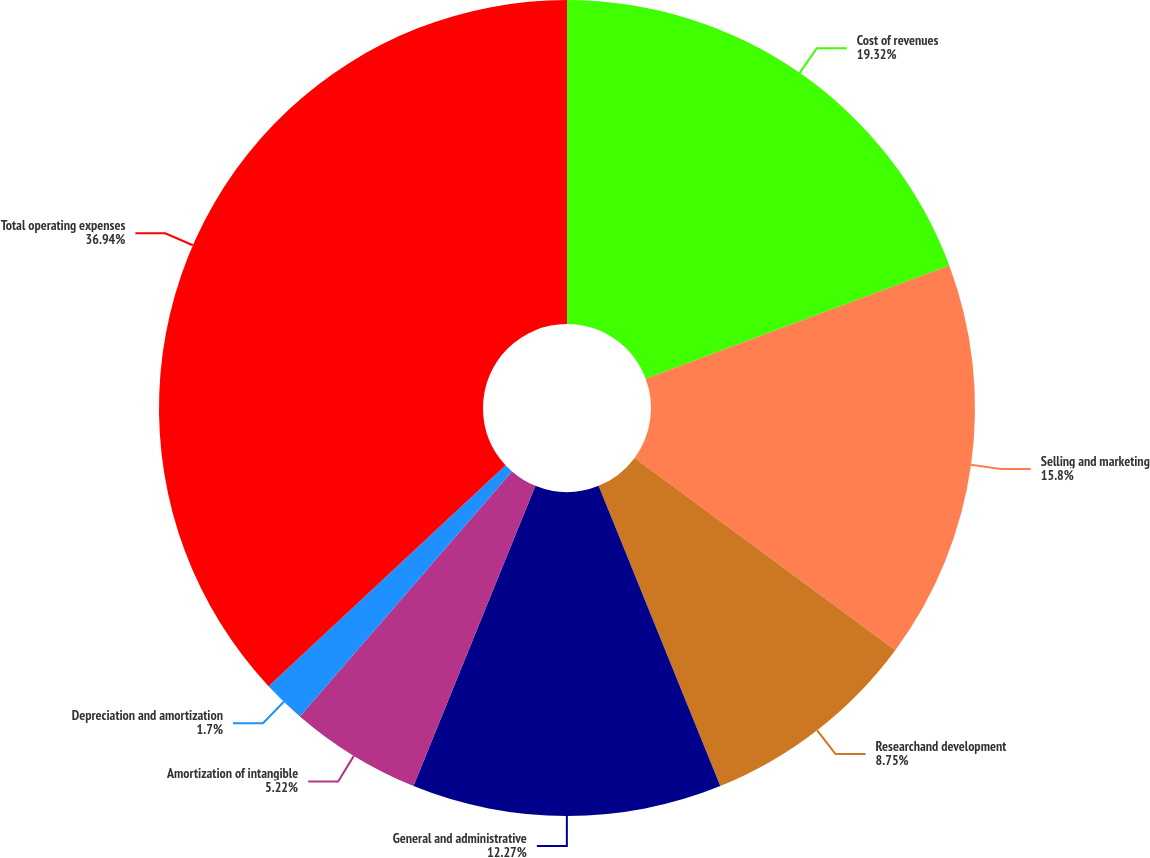Convert chart. <chart><loc_0><loc_0><loc_500><loc_500><pie_chart><fcel>Cost of revenues<fcel>Selling and marketing<fcel>Researchand development<fcel>General and administrative<fcel>Amortization of intangible<fcel>Depreciation and amortization<fcel>Total operating expenses<nl><fcel>19.32%<fcel>15.8%<fcel>8.75%<fcel>12.27%<fcel>5.22%<fcel>1.7%<fcel>36.94%<nl></chart> 